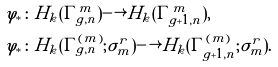Convert formula to latex. <formula><loc_0><loc_0><loc_500><loc_500>\varphi _ { * } & \colon H _ { k } ( \Gamma _ { g , n } ^ { m } ) \longrightarrow H _ { k } ( \Gamma _ { g + 1 , n } ^ { m } ) , \\ \varphi _ { * } & \colon H _ { k } ( \Gamma _ { g , n } ^ { ( m ) } ; \sigma _ { m } ^ { r } ) \longrightarrow H _ { k } ( \Gamma _ { g + 1 , n } ^ { ( m ) } ; \sigma _ { m } ^ { r } ) .</formula> 